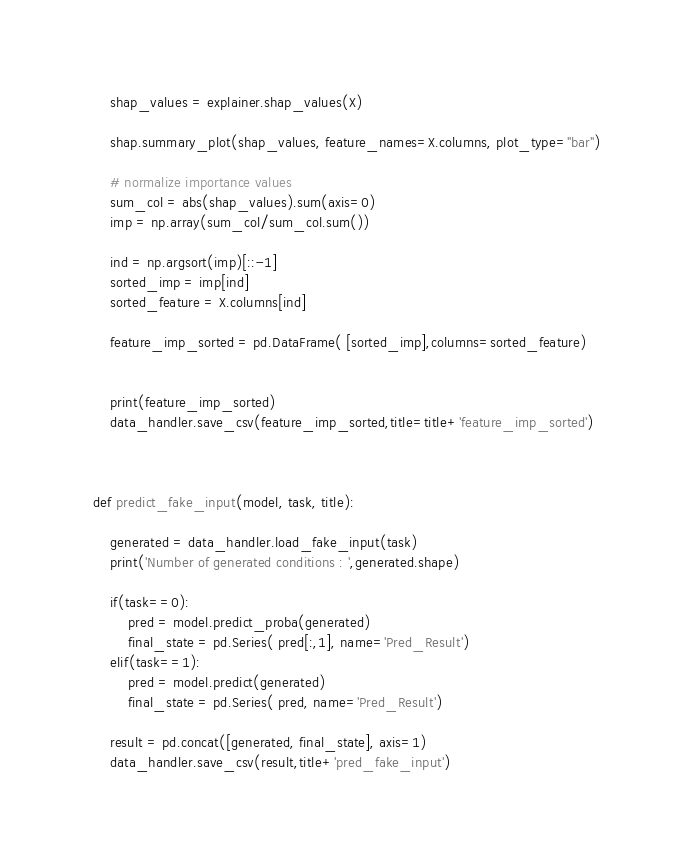Convert code to text. <code><loc_0><loc_0><loc_500><loc_500><_Python_>    shap_values = explainer.shap_values(X)

    shap.summary_plot(shap_values, feature_names=X.columns, plot_type="bar")

    # normalize importance values
    sum_col = abs(shap_values).sum(axis=0)
    imp = np.array(sum_col/sum_col.sum())

    ind = np.argsort(imp)[::-1]
    sorted_imp = imp[ind]
    sorted_feature = X.columns[ind]

    feature_imp_sorted = pd.DataFrame( [sorted_imp],columns=sorted_feature)
    
    
    print(feature_imp_sorted)
    data_handler.save_csv(feature_imp_sorted,title=title+'feature_imp_sorted')
    
    
    
def predict_fake_input(model, task, title):
    
    generated = data_handler.load_fake_input(task)
    print('Number of generated conditions : ',generated.shape)
    
    if(task==0):
        pred = model.predict_proba(generated)
        final_state = pd.Series( pred[:,1], name='Pred_Result')
    elif(task==1):
        pred = model.predict(generated)
        final_state = pd.Series( pred, name='Pred_Result')

    result = pd.concat([generated, final_state], axis=1)
    data_handler.save_csv(result,title+'pred_fake_input')</code> 